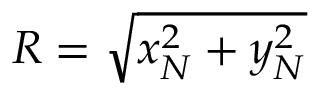Convert formula to latex. <formula><loc_0><loc_0><loc_500><loc_500>R = \sqrt { x _ { N } ^ { 2 } + y _ { N } ^ { 2 } }</formula> 